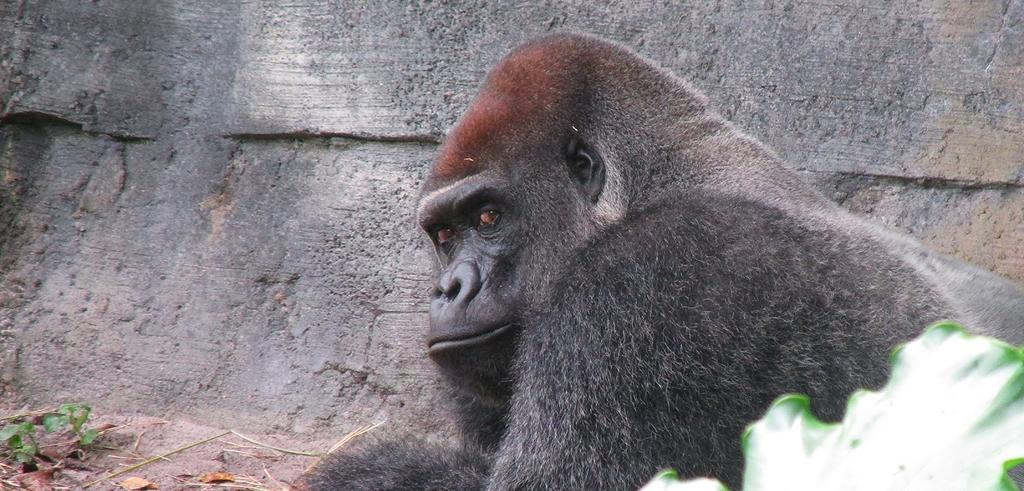What type of living creature is present in the image? There is an animal in the image. What type of furniture is being played by the band in the image? There is no band or furniture present in the image; it only features an animal. 